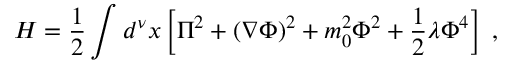<formula> <loc_0><loc_0><loc_500><loc_500>H = \frac { 1 } { 2 } \int d ^ { \nu } x \left [ \Pi ^ { 2 } + ( \nabla \Phi ) ^ { 2 } + m _ { 0 } ^ { 2 } \Phi ^ { 2 } + \frac { 1 } { 2 } \lambda \Phi ^ { 4 } \right ] \, ,</formula> 